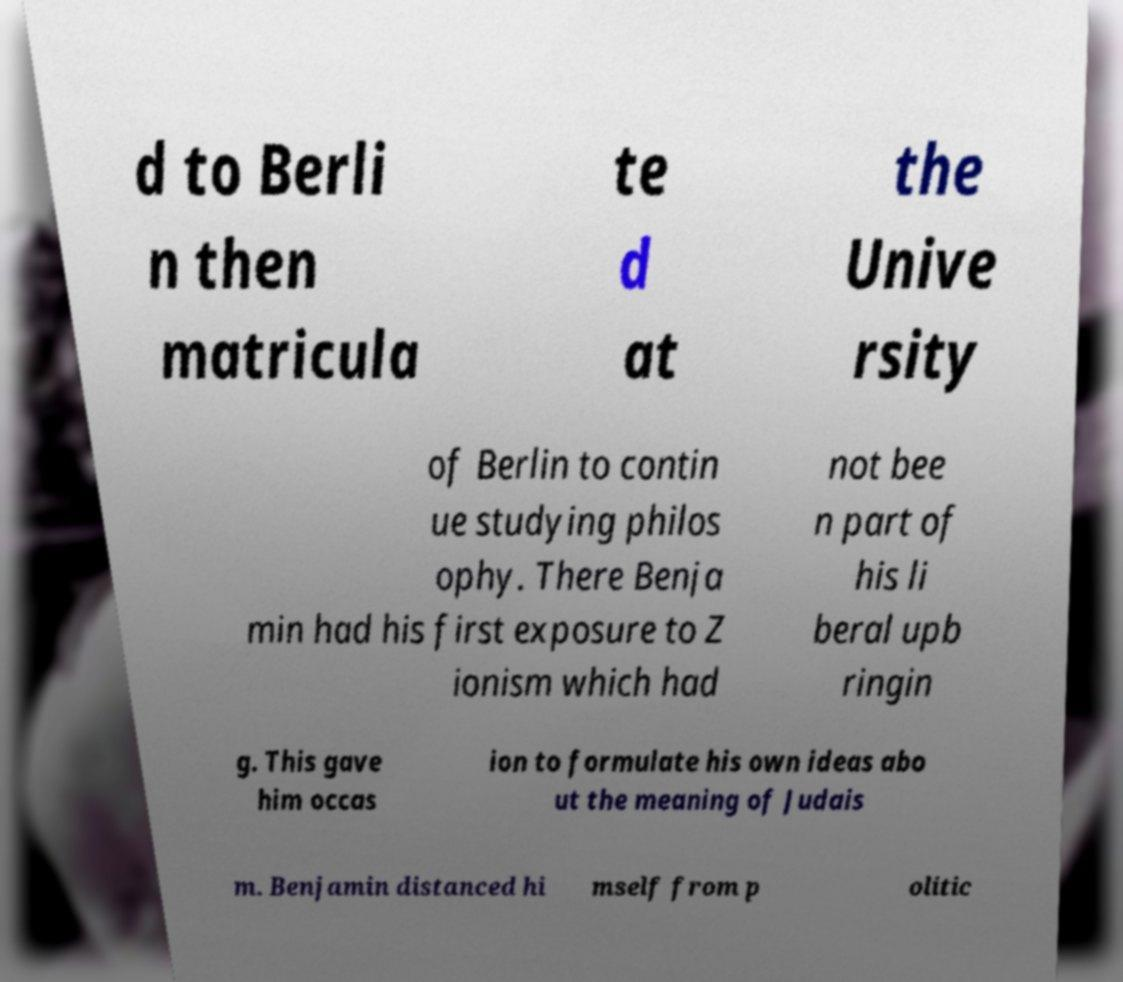Can you read and provide the text displayed in the image?This photo seems to have some interesting text. Can you extract and type it out for me? d to Berli n then matricula te d at the Unive rsity of Berlin to contin ue studying philos ophy. There Benja min had his first exposure to Z ionism which had not bee n part of his li beral upb ringin g. This gave him occas ion to formulate his own ideas abo ut the meaning of Judais m. Benjamin distanced hi mself from p olitic 